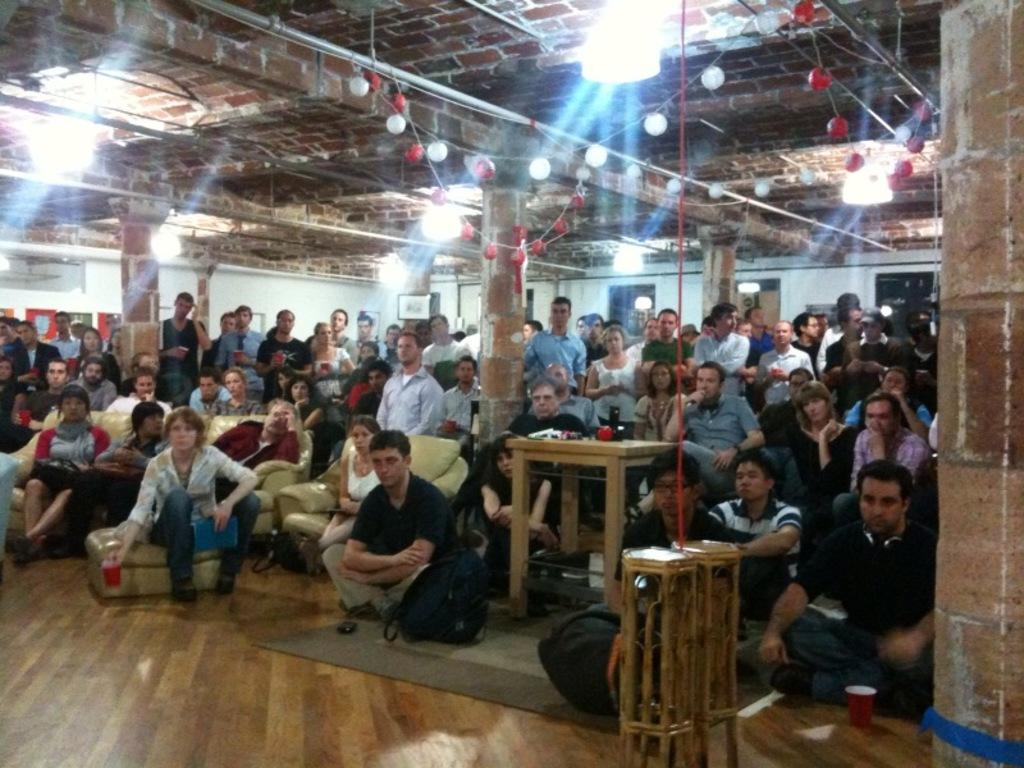What type of structure is visible in the image? There is a brick wall in the image. What are the people in the image doing? The people in the image are standing and sitting. What type of furniture is in the front of the image? There are sofas in the front of the image. What object related to travel can be seen in the front of the image? There is a suitcase in the front of the image. What piece of furniture is present for placing items or serving food? There is a table in the image. What type of comb is being used by the person in the image? There is no comb visible in the image. Who is the representative of the group in the image? A: The image does not depict a group or any representative. 